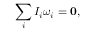<formula> <loc_0><loc_0><loc_500><loc_500>\sum _ { i } I _ { i } { \omega } _ { i } = 0 ,</formula> 